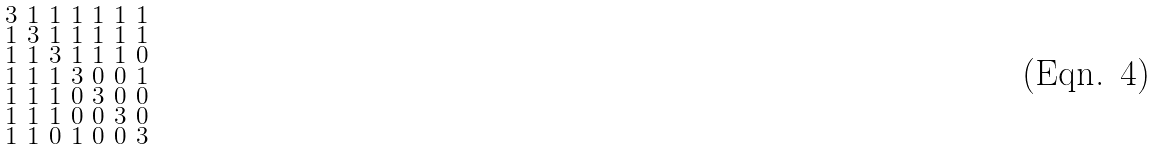<formula> <loc_0><loc_0><loc_500><loc_500>\begin{smallmatrix} 3 & 1 & 1 & 1 & 1 & 1 & 1 \\ 1 & 3 & 1 & 1 & 1 & 1 & 1 \\ 1 & 1 & 3 & 1 & 1 & 1 & 0 \\ 1 & 1 & 1 & 3 & 0 & 0 & 1 \\ 1 & 1 & 1 & 0 & 3 & 0 & 0 \\ 1 & 1 & 1 & 0 & 0 & 3 & 0 \\ 1 & 1 & 0 & 1 & 0 & 0 & 3 \end{smallmatrix}</formula> 